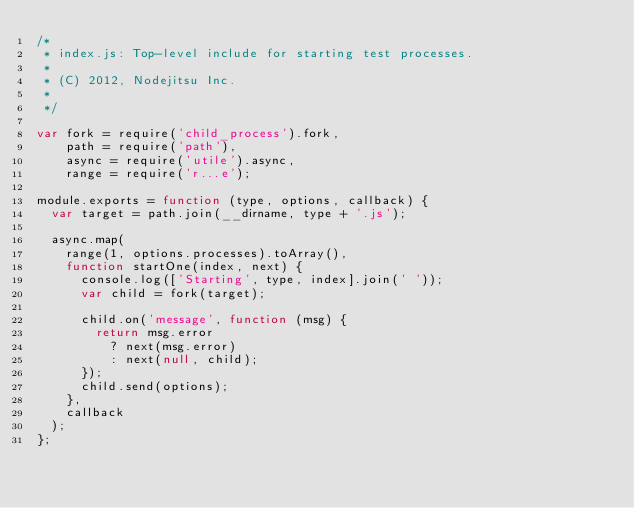Convert code to text. <code><loc_0><loc_0><loc_500><loc_500><_JavaScript_>/*
 * index.js: Top-level include for starting test processes.
 *
 * (C) 2012, Nodejitsu Inc.
 *
 */

var fork = require('child_process').fork,
    path = require('path'),
    async = require('utile').async,
    range = require('r...e');

module.exports = function (type, options, callback) {
  var target = path.join(__dirname, type + '.js');
  
  async.map(
    range(1, options.processes).toArray(),
    function startOne(index, next) {
      console.log(['Starting', type, index].join(' '));
      var child = fork(target);
      
      child.on('message', function (msg) {
        return msg.error
          ? next(msg.error)
          : next(null, child);
      });
      child.send(options);
    },
    callback
  );
};</code> 